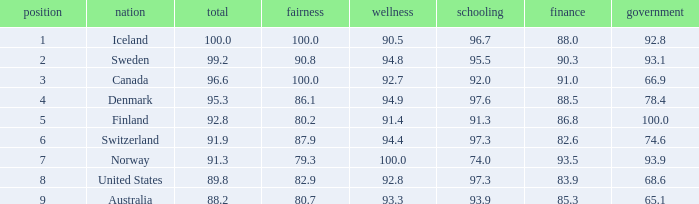What's the economics score with justice being 90.8 90.3. 